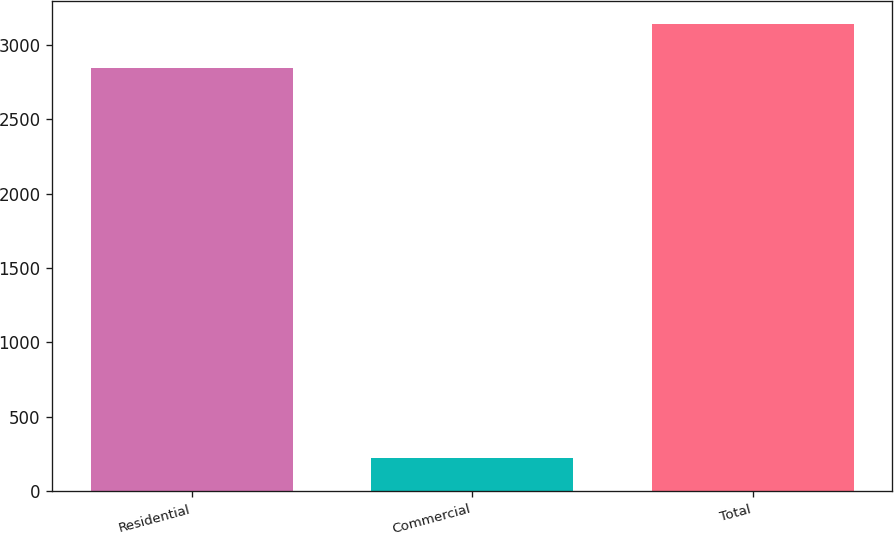<chart> <loc_0><loc_0><loc_500><loc_500><bar_chart><fcel>Residential<fcel>Commercial<fcel>Total<nl><fcel>2846<fcel>220<fcel>3137.1<nl></chart> 